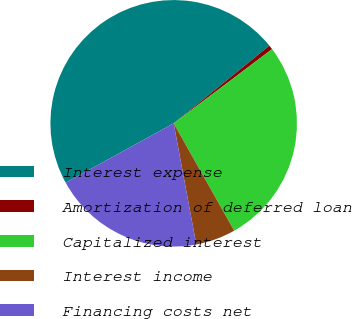Convert chart. <chart><loc_0><loc_0><loc_500><loc_500><pie_chart><fcel>Interest expense<fcel>Amortization of deferred loan<fcel>Capitalized interest<fcel>Interest income<fcel>Financing costs net<nl><fcel>47.15%<fcel>0.57%<fcel>27.12%<fcel>5.23%<fcel>19.94%<nl></chart> 